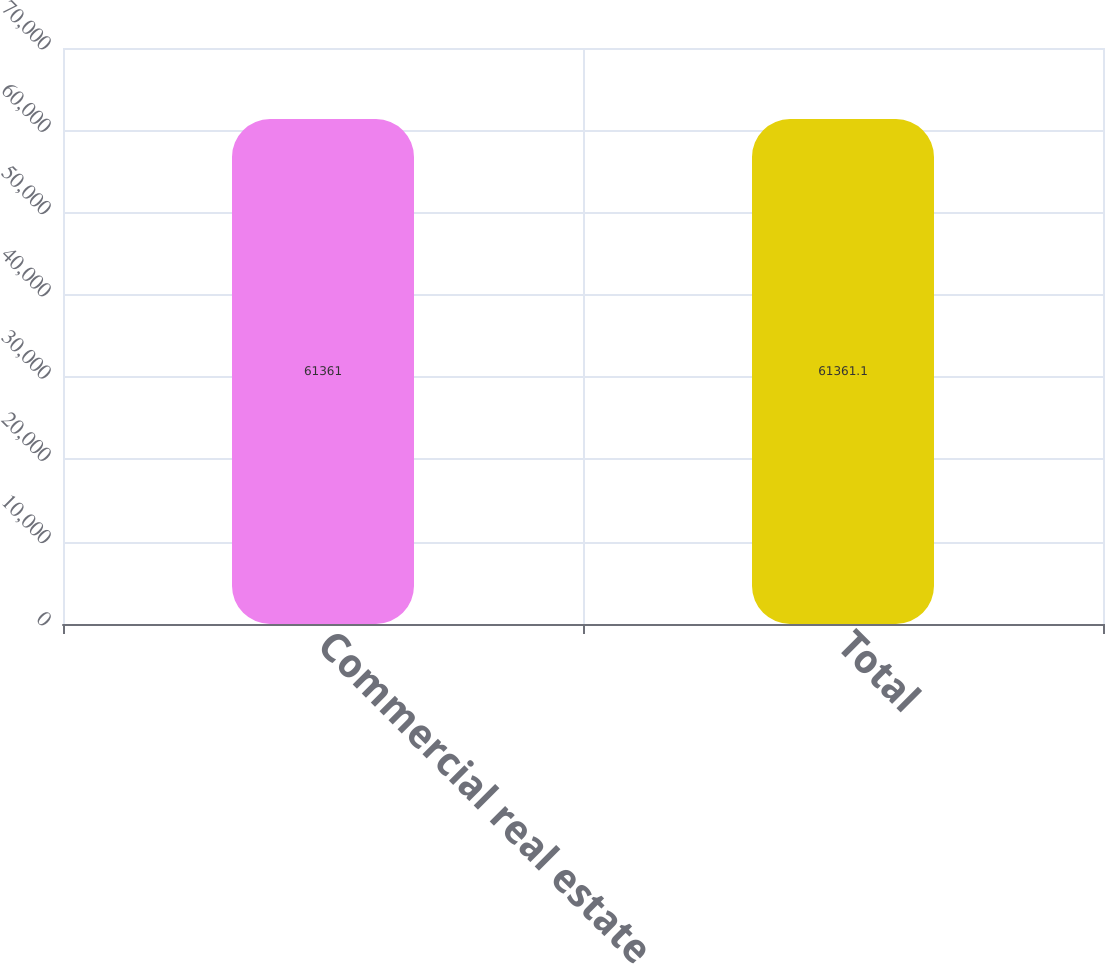Convert chart to OTSL. <chart><loc_0><loc_0><loc_500><loc_500><bar_chart><fcel>Commercial real estate<fcel>Total<nl><fcel>61361<fcel>61361.1<nl></chart> 